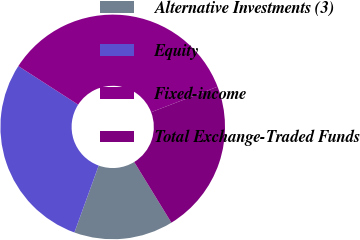Convert chart to OTSL. <chart><loc_0><loc_0><loc_500><loc_500><pie_chart><fcel>Alternative Investments (3)<fcel>Equity<fcel>Fixed-income<fcel>Total Exchange-Traded Funds<nl><fcel>14.29%<fcel>28.57%<fcel>35.06%<fcel>22.08%<nl></chart> 